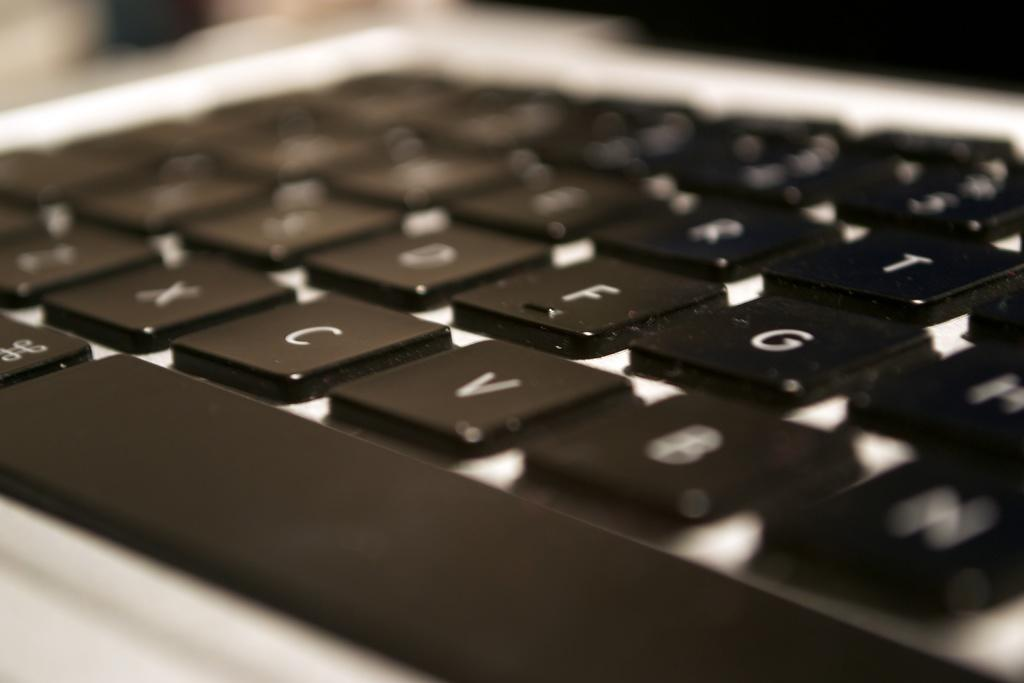Provide a one-sentence caption for the provided image. The black keys of a keyboard of which the letter N is at the bottom right. 